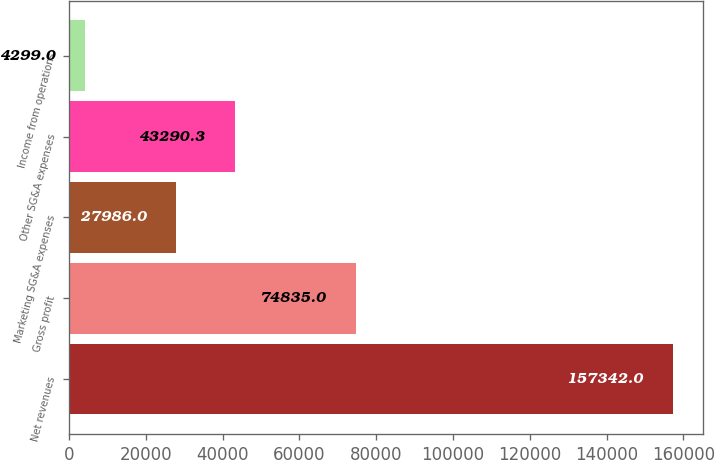<chart> <loc_0><loc_0><loc_500><loc_500><bar_chart><fcel>Net revenues<fcel>Gross profit<fcel>Marketing SG&A expenses<fcel>Other SG&A expenses<fcel>Income from operations<nl><fcel>157342<fcel>74835<fcel>27986<fcel>43290.3<fcel>4299<nl></chart> 